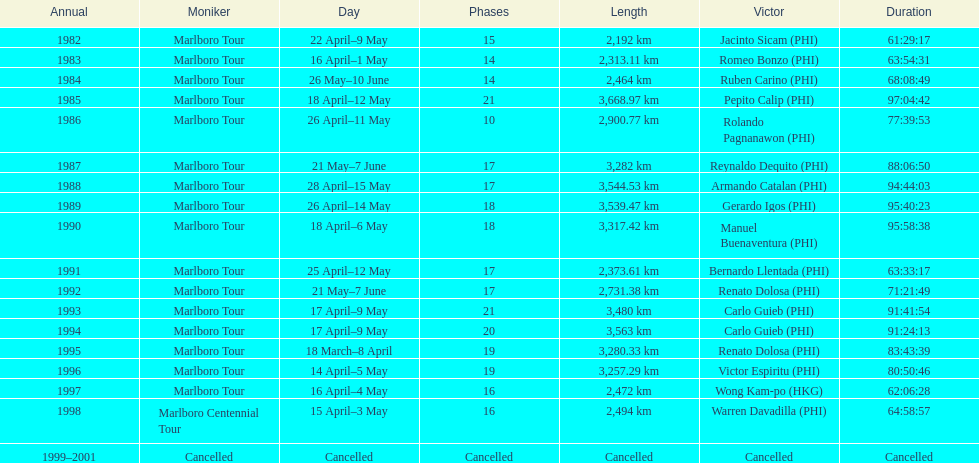Who was the only winner to have their time below 61:45:00? Jacinto Sicam. 